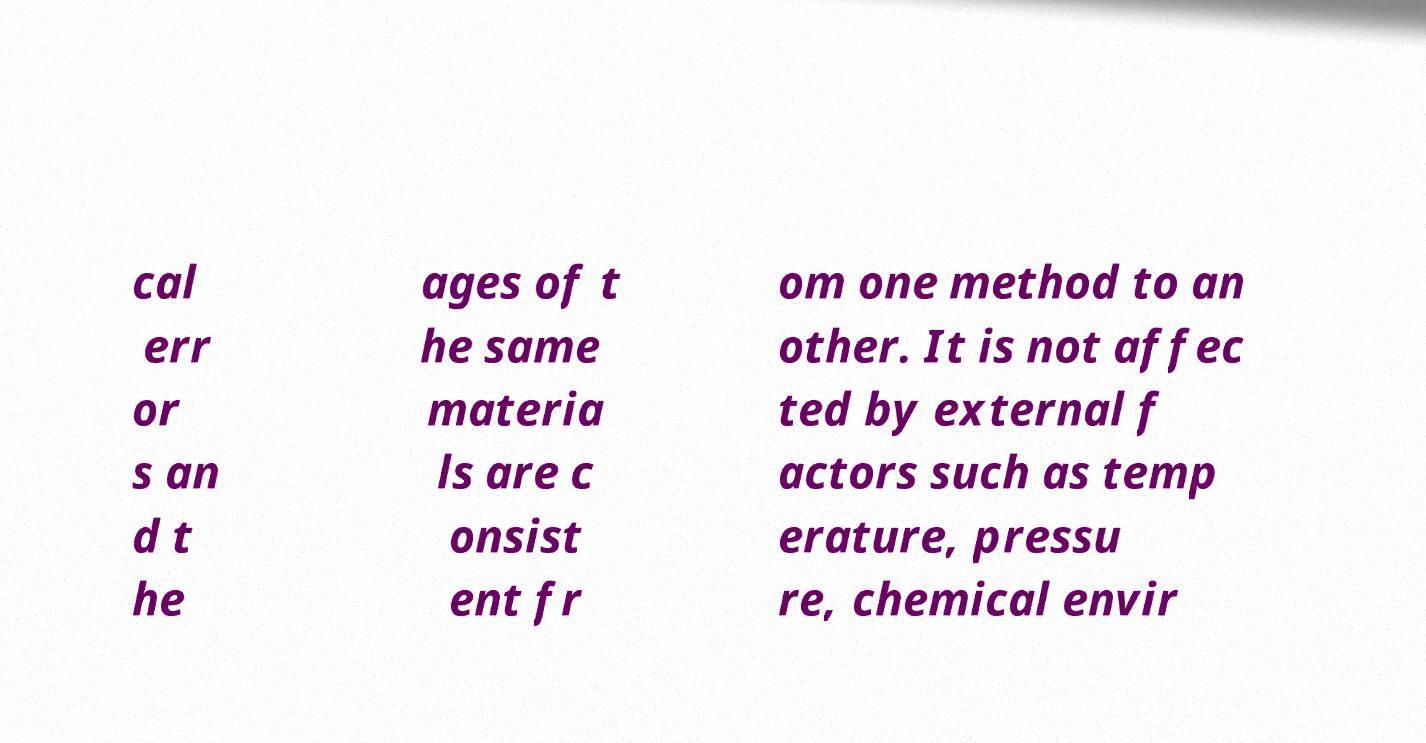What messages or text are displayed in this image? I need them in a readable, typed format. cal err or s an d t he ages of t he same materia ls are c onsist ent fr om one method to an other. It is not affec ted by external f actors such as temp erature, pressu re, chemical envir 